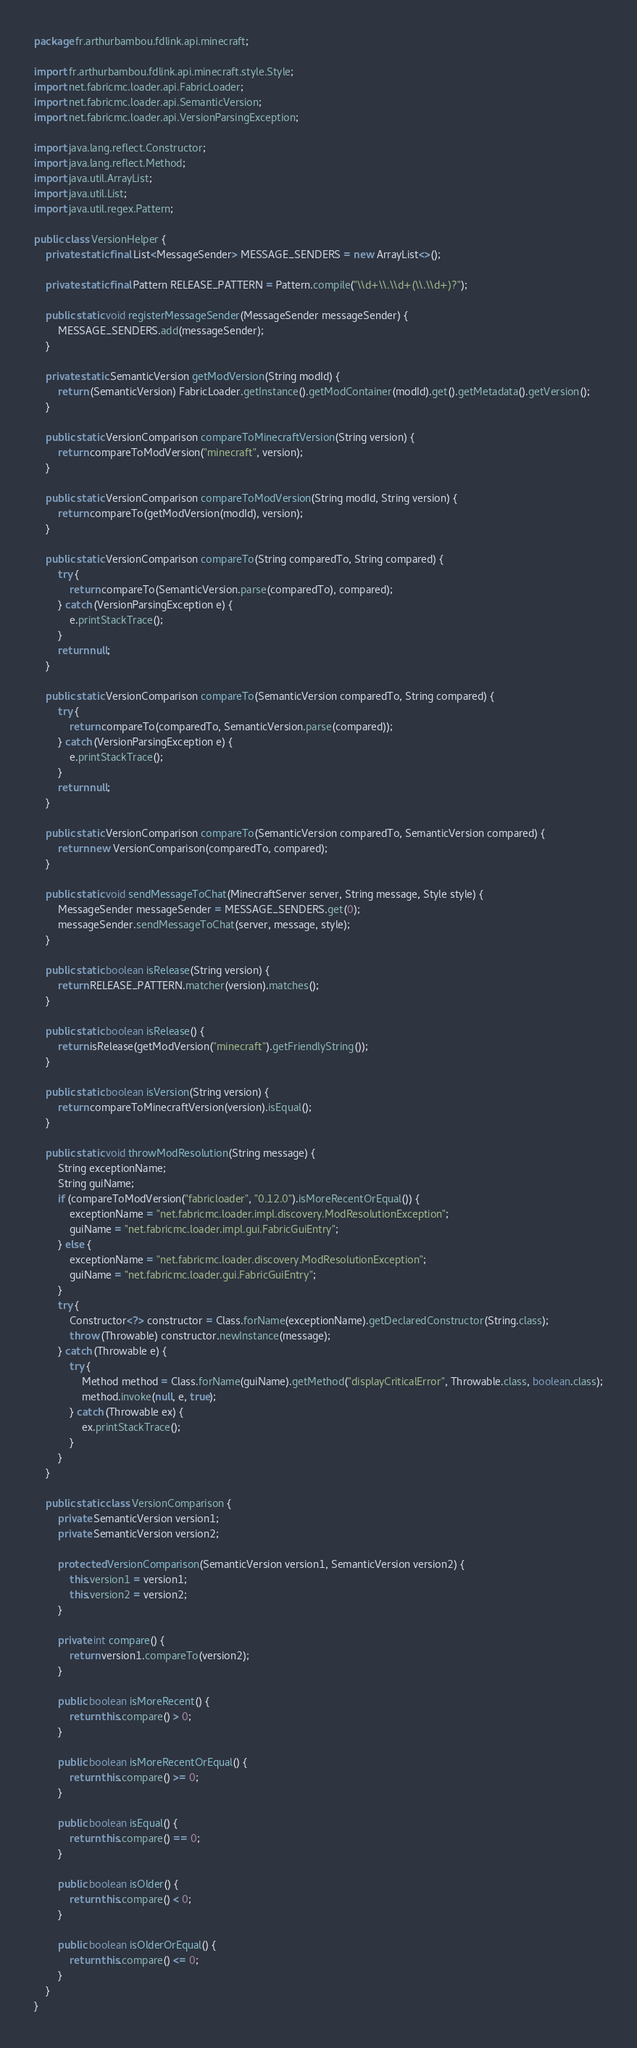<code> <loc_0><loc_0><loc_500><loc_500><_Java_>package fr.arthurbambou.fdlink.api.minecraft;

import fr.arthurbambou.fdlink.api.minecraft.style.Style;
import net.fabricmc.loader.api.FabricLoader;
import net.fabricmc.loader.api.SemanticVersion;
import net.fabricmc.loader.api.VersionParsingException;

import java.lang.reflect.Constructor;
import java.lang.reflect.Method;
import java.util.ArrayList;
import java.util.List;
import java.util.regex.Pattern;

public class VersionHelper {
    private static final List<MessageSender> MESSAGE_SENDERS = new ArrayList<>();

    private static final Pattern RELEASE_PATTERN = Pattern.compile("\\d+\\.\\d+(\\.\\d+)?");

    public static void registerMessageSender(MessageSender messageSender) {
        MESSAGE_SENDERS.add(messageSender);
    }

    private static SemanticVersion getModVersion(String modId) {
        return (SemanticVersion) FabricLoader.getInstance().getModContainer(modId).get().getMetadata().getVersion();
    }

    public static VersionComparison compareToMinecraftVersion(String version) {
        return compareToModVersion("minecraft", version);
    }

    public static VersionComparison compareToModVersion(String modId, String version) {
        return compareTo(getModVersion(modId), version);
    }

    public static VersionComparison compareTo(String comparedTo, String compared) {
        try {
            return compareTo(SemanticVersion.parse(comparedTo), compared);
        } catch (VersionParsingException e) {
            e.printStackTrace();
        }
        return null;
    }

    public static VersionComparison compareTo(SemanticVersion comparedTo, String compared) {
        try {
            return compareTo(comparedTo, SemanticVersion.parse(compared));
        } catch (VersionParsingException e) {
            e.printStackTrace();
        }
        return null;
    }

    public static VersionComparison compareTo(SemanticVersion comparedTo, SemanticVersion compared) {
        return new VersionComparison(comparedTo, compared);
    }

    public static void sendMessageToChat(MinecraftServer server, String message, Style style) {
        MessageSender messageSender = MESSAGE_SENDERS.get(0);
        messageSender.sendMessageToChat(server, message, style);
    }

    public static boolean isRelease(String version) {
        return RELEASE_PATTERN.matcher(version).matches();
    }

    public static boolean isRelease() {
        return isRelease(getModVersion("minecraft").getFriendlyString());
    }

    public static boolean isVersion(String version) {
        return compareToMinecraftVersion(version).isEqual();
    }

    public static void throwModResolution(String message) {
        String exceptionName;
        String guiName;
        if (compareToModVersion("fabricloader", "0.12.0").isMoreRecentOrEqual()) {
            exceptionName = "net.fabricmc.loader.impl.discovery.ModResolutionException";
            guiName = "net.fabricmc.loader.impl.gui.FabricGuiEntry";
        } else {
            exceptionName = "net.fabricmc.loader.discovery.ModResolutionException";
            guiName = "net.fabricmc.loader.gui.FabricGuiEntry";
        }
        try {
            Constructor<?> constructor = Class.forName(exceptionName).getDeclaredConstructor(String.class);
            throw (Throwable) constructor.newInstance(message);
        } catch (Throwable e) {
            try {
                Method method = Class.forName(guiName).getMethod("displayCriticalError", Throwable.class, boolean.class);
                method.invoke(null, e, true);
            } catch (Throwable ex) {
                ex.printStackTrace();
            }
        }
    }

    public static class VersionComparison {
        private SemanticVersion version1;
        private SemanticVersion version2;

        protected VersionComparison(SemanticVersion version1, SemanticVersion version2) {
            this.version1 = version1;
            this.version2 = version2;
        }

        private int compare() {
            return version1.compareTo(version2);
        }

        public boolean isMoreRecent() {
            return this.compare() > 0;
        }

        public boolean isMoreRecentOrEqual() {
            return this.compare() >= 0;
        }

        public boolean isEqual() {
            return this.compare() == 0;
        }

        public boolean isOlder() {
            return this.compare() < 0;
        }

        public boolean isOlderOrEqual() {
            return this.compare() <= 0;
        }
    }
}
</code> 